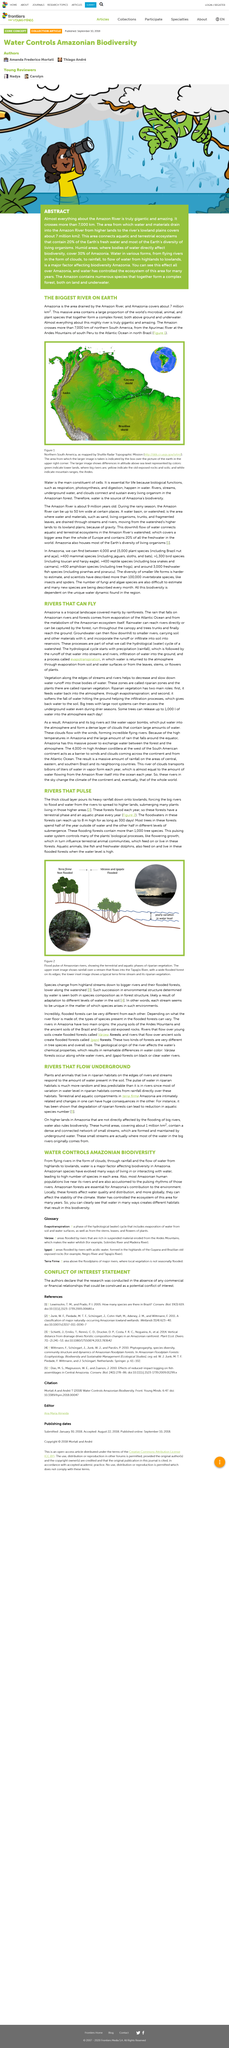Outline some significant characteristics in this image. The Amazon River is a vast waterway that spans more than 7,000 kilometers across the northern region of South America. The pulse of water in riparian habitats is much more random and less predictable than it is in rivers due to the water level being directly influenced by rainfall in these habitats. The major factor that affects biodiversity in Amazonia is water. The degradation of reparian forests can result in a decrease in the number of aquatic species. Water plays a crucial role in shaping the biodiversity of the Amazon rainforest by creating a variety of habitats. These habitats, in turn, support a rich and diverse array of plant and animal species. The unique hydrological characteristics of the region, including the seasonal flooding of the Amazon River and its tributaries, create a range of ecological conditions that are conducive to the growth and survival of different plant and animal species. As a result, the Amazon rainforest is home to an incredible number of different species, making it one of the most biodiverse regions on Earth. 